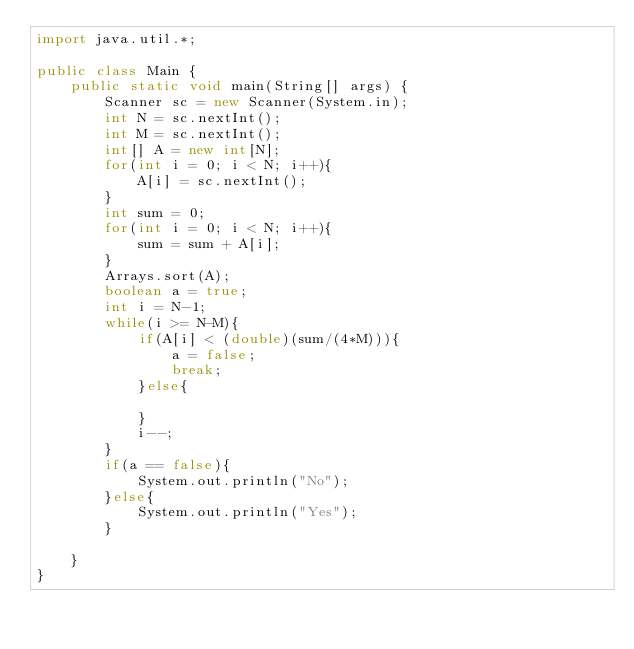Convert code to text. <code><loc_0><loc_0><loc_500><loc_500><_Java_>import java.util.*;

public class Main {
    public static void main(String[] args) {
        Scanner sc = new Scanner(System.in);
        int N = sc.nextInt();
        int M = sc.nextInt();
        int[] A = new int[N];
        for(int i = 0; i < N; i++){
            A[i] = sc.nextInt();
        }
        int sum = 0;
        for(int i = 0; i < N; i++){
            sum = sum + A[i];
        }
        Arrays.sort(A);
        boolean a = true;
        int i = N-1;
        while(i >= N-M){
            if(A[i] < (double)(sum/(4*M))){
                a = false;
                break;
            }else{
                
            }
            i--;
        }
        if(a == false){
            System.out.println("No");
        }else{
            System.out.println("Yes");
        }
        
    }
} </code> 